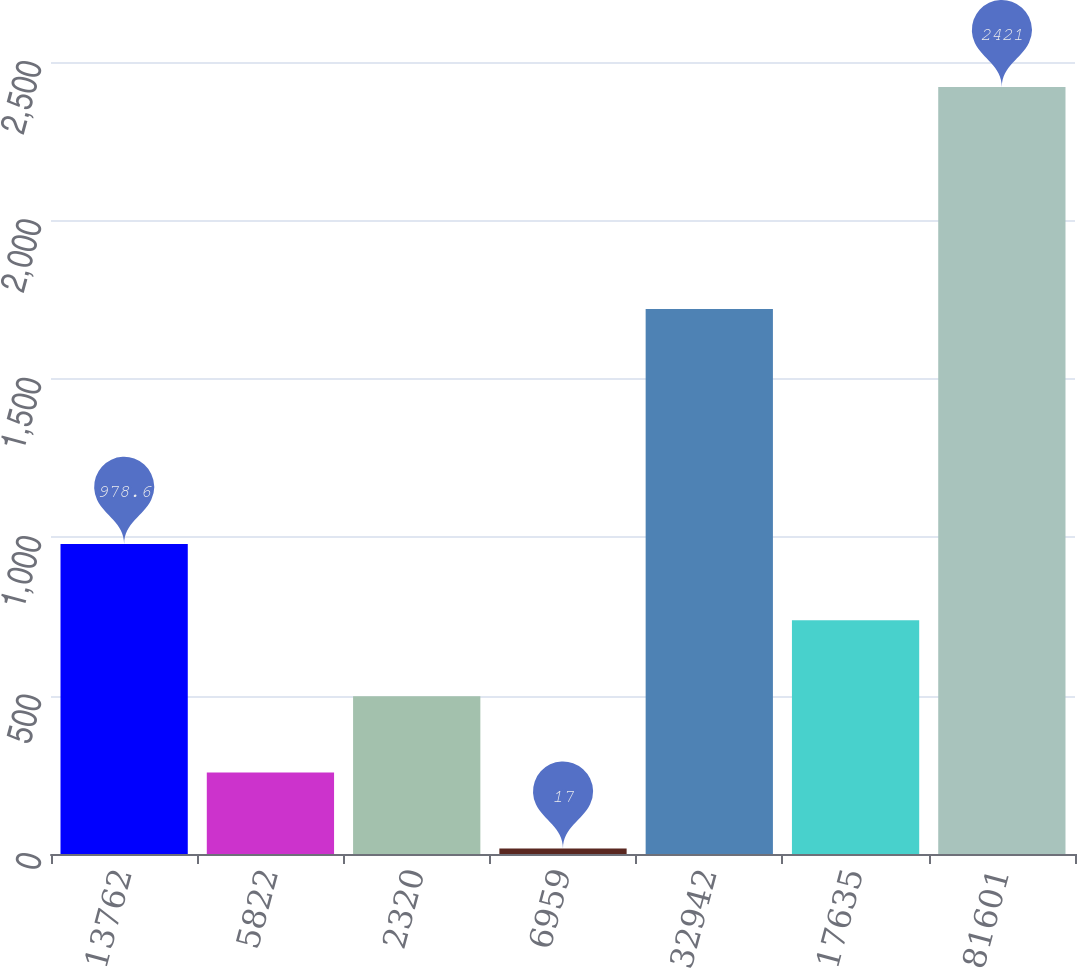Convert chart. <chart><loc_0><loc_0><loc_500><loc_500><bar_chart><fcel>13762<fcel>5822<fcel>2320<fcel>6959<fcel>32942<fcel>17635<fcel>81601<nl><fcel>978.6<fcel>257.4<fcel>497.8<fcel>17<fcel>1720<fcel>738.2<fcel>2421<nl></chart> 